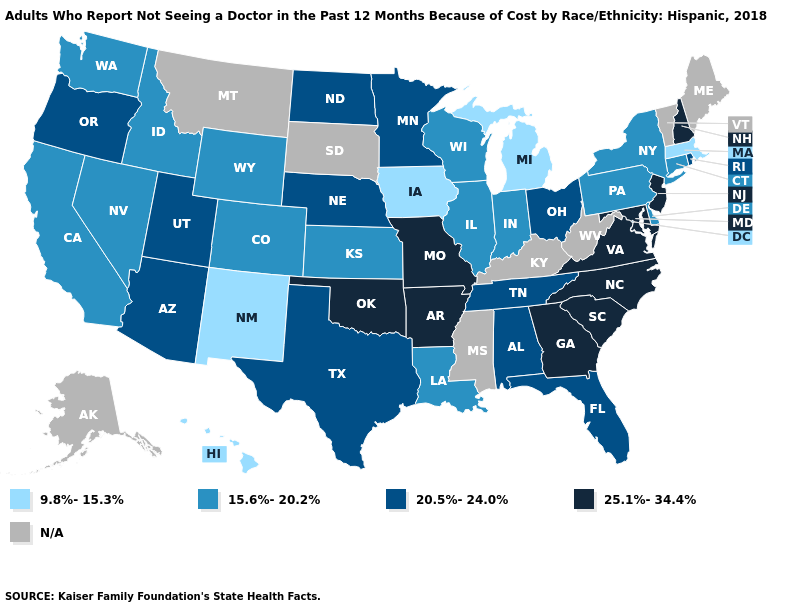What is the value of Florida?
Give a very brief answer. 20.5%-24.0%. What is the value of Utah?
Short answer required. 20.5%-24.0%. Does Iowa have the lowest value in the MidWest?
Be succinct. Yes. Name the states that have a value in the range 9.8%-15.3%?
Concise answer only. Hawaii, Iowa, Massachusetts, Michigan, New Mexico. What is the value of Washington?
Keep it brief. 15.6%-20.2%. Name the states that have a value in the range 15.6%-20.2%?
Be succinct. California, Colorado, Connecticut, Delaware, Idaho, Illinois, Indiana, Kansas, Louisiana, Nevada, New York, Pennsylvania, Washington, Wisconsin, Wyoming. What is the highest value in states that border Pennsylvania?
Keep it brief. 25.1%-34.4%. Name the states that have a value in the range N/A?
Short answer required. Alaska, Kentucky, Maine, Mississippi, Montana, South Dakota, Vermont, West Virginia. What is the value of Texas?
Concise answer only. 20.5%-24.0%. What is the highest value in the USA?
Give a very brief answer. 25.1%-34.4%. Name the states that have a value in the range 15.6%-20.2%?
Short answer required. California, Colorado, Connecticut, Delaware, Idaho, Illinois, Indiana, Kansas, Louisiana, Nevada, New York, Pennsylvania, Washington, Wisconsin, Wyoming. Among the states that border Arkansas , does Louisiana have the highest value?
Write a very short answer. No. What is the value of New Jersey?
Short answer required. 25.1%-34.4%. What is the highest value in the MidWest ?
Concise answer only. 25.1%-34.4%. Name the states that have a value in the range 25.1%-34.4%?
Write a very short answer. Arkansas, Georgia, Maryland, Missouri, New Hampshire, New Jersey, North Carolina, Oklahoma, South Carolina, Virginia. 